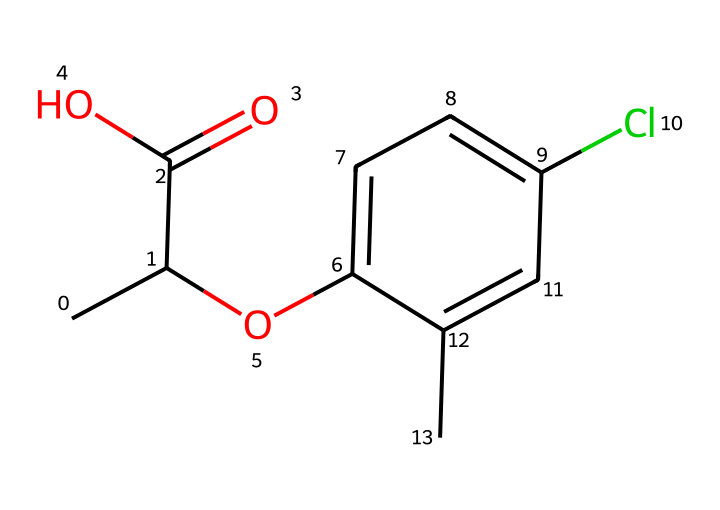How many carbon atoms are in mecoprop? By analyzing the SMILES representation, we count the number of carbon atoms represented. There are 8 carbon atoms in total (CC(C(=O)O)Oc1ccc(Cl)cc1C).
Answer: 8 What functional groups are present in mecoprop? Upon examining the structure, we identify an ester (from the O-C bond), a carboxylic acid (C(=O)O), and a phenolic hydroxyl group (attached to the aromatic ring).
Answer: ester, carboxylic acid, phenolic Is mecoprop a solid, liquid, or gas at room temperature? Given that mecoprop is a selective herbicide used in turf management, it is typically solid at room temperature.
Answer: solid What type of herbicide is mecoprop? The structure displays selectivity towards certain plant species, indicating it is a selective herbicide commonly used in turf management.
Answer: selective How many chlorine atoms are in mecoprop's structure? The SMILES notation includes one 'Cl', indicating there is one chlorine atom present in the molecular structure.
Answer: 1 What is the primary purpose of mecoprop? Given that mecoprop is used in turf management, its primary purpose is to control unwanted broadleaf weeds while preserving grass species.
Answer: weed control What aspect of mecoprop's structure contributes to its selectivity as a herbicide? The specific arrangement of functional groups and the presence of a chlorine atom within the aromatic ring allow mecoprop to selectively target certain plant pathways, thus contributing to its herbicidal properties.
Answer: functional groups and chlorine 